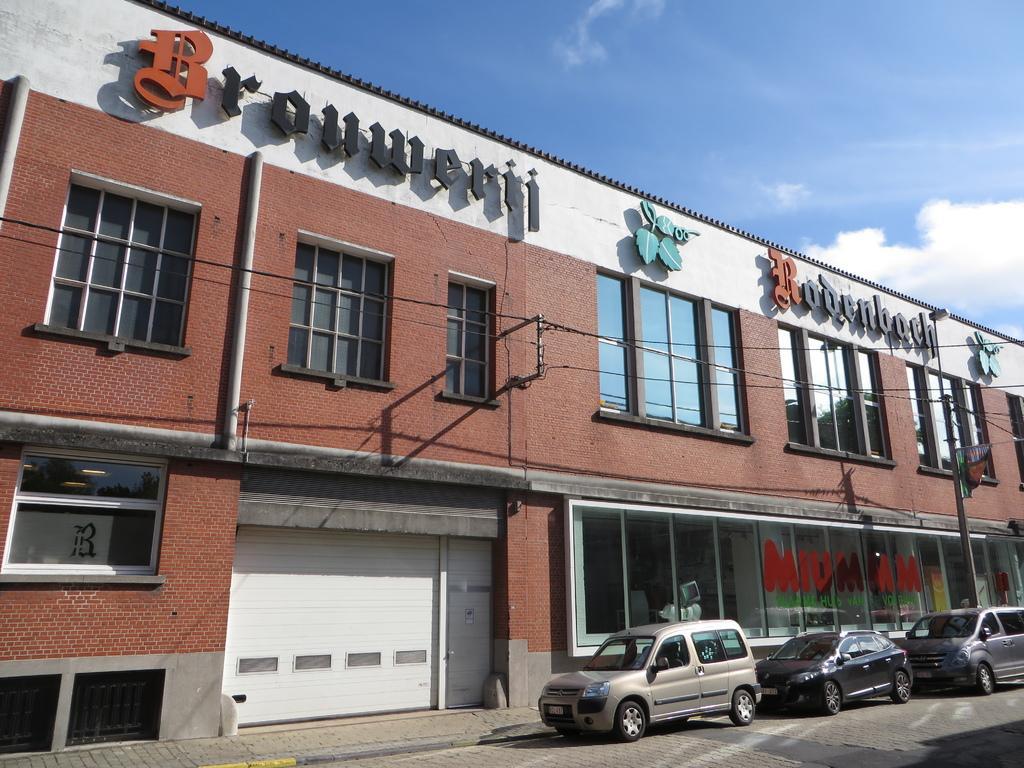Could you give a brief overview of what you see in this image? In this picture we see three cars at the right side and one building and here this white color is the shutter and something was written at top. 